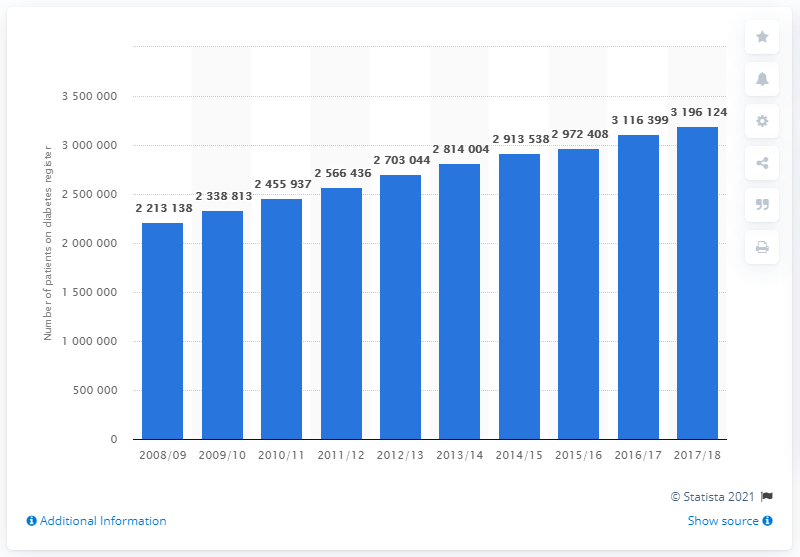List a handful of essential elements in this visual. In the year 2017/2018, it is estimated that 3,196,124 people in England were diagnosed with diabetes. 